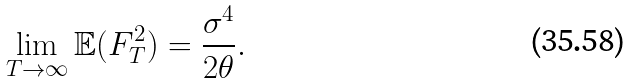<formula> <loc_0><loc_0><loc_500><loc_500>\lim _ { T \rightarrow \infty } \mathbb { E } ( F _ { T } ^ { 2 } ) = \frac { \sigma ^ { 4 } } { 2 \theta } .</formula> 